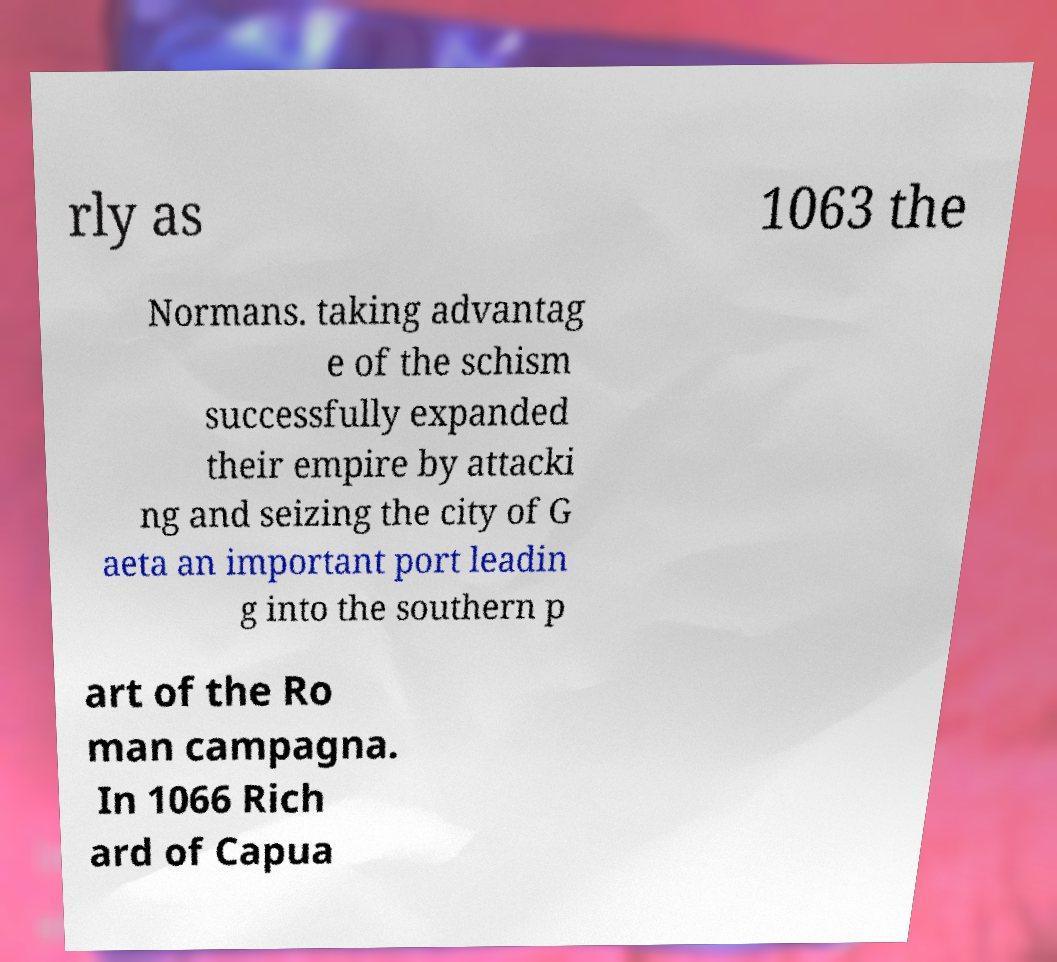Please read and relay the text visible in this image. What does it say? rly as 1063 the Normans. taking advantag e of the schism successfully expanded their empire by attacki ng and seizing the city of G aeta an important port leadin g into the southern p art of the Ro man campagna. In 1066 Rich ard of Capua 